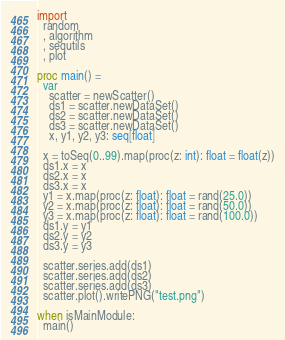<code> <loc_0><loc_0><loc_500><loc_500><_Nim_>import
  random
  , algorithm
  , sequtils
  , plot

proc main() =
  var
    scatter = newScatter()
    ds1 = scatter.newDataSet()
    ds2 = scatter.newDataSet()
    ds3 = scatter.newDataSet()
    x, y1, y2, y3: seq[float]

  x = toSeq(0..99).map(proc(z: int): float = float(z))
  ds1.x = x
  ds2.x = x
  ds3.x = x
  y1 = x.map(proc(z: float): float = rand(25.0))
  y2 = x.map(proc(z: float): float = rand(50.0))
  y3 = x.map(proc(z: float): float = rand(100.0))
  ds1.y = y1
  ds2.y = y2
  ds3.y = y3

  scatter.series.add(ds1)
  scatter.series.add(ds2)
  scatter.series.add(ds3)
  scatter.plot().writePNG("test.png")

when isMainModule:
  main()
</code> 